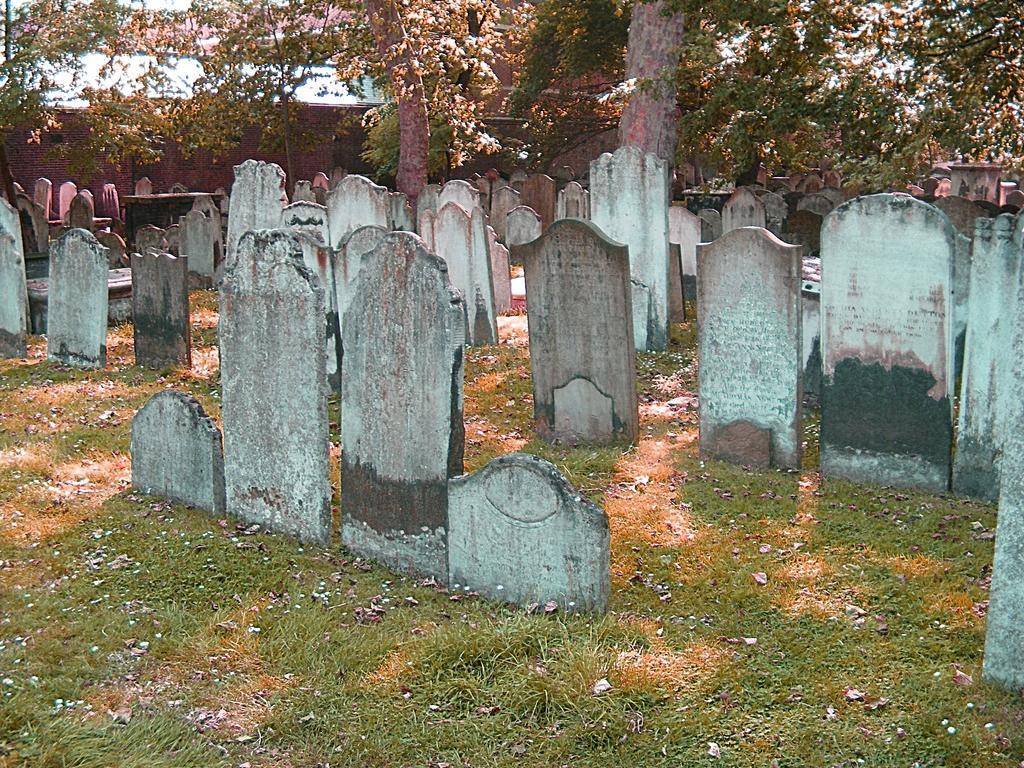Describe this image in one or two sentences. In this image there is a land, on that land there are headstones and trees. 